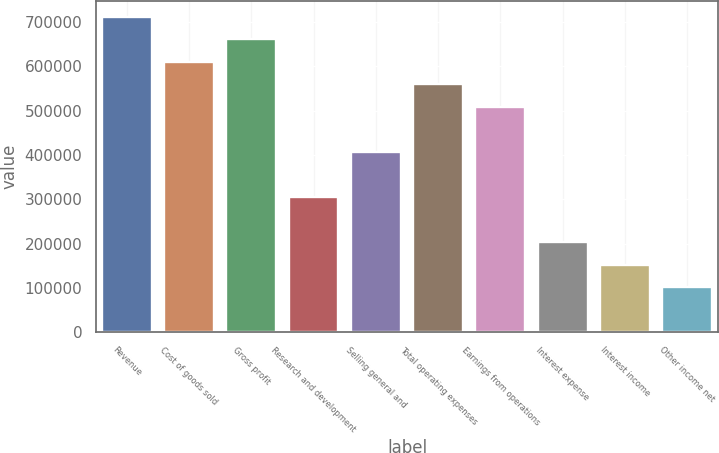Convert chart. <chart><loc_0><loc_0><loc_500><loc_500><bar_chart><fcel>Revenue<fcel>Cost of goods sold<fcel>Gross profit<fcel>Research and development<fcel>Selling general and<fcel>Total operating expenses<fcel>Earnings from operations<fcel>Interest expense<fcel>Interest income<fcel>Other income net<nl><fcel>711985<fcel>610273<fcel>661129<fcel>305137<fcel>406849<fcel>559417<fcel>508561<fcel>203425<fcel>152569<fcel>101713<nl></chart> 